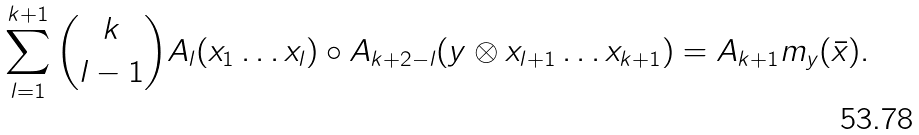Convert formula to latex. <formula><loc_0><loc_0><loc_500><loc_500>\sum _ { l = 1 } ^ { k + 1 } { k \choose l - 1 } A _ { l } ( x _ { 1 } \dots x _ { l } ) \circ A _ { k + 2 - l } ( y \otimes x _ { l + 1 } \dots x _ { k + 1 } ) = A _ { k + 1 } m _ { y } ( \bar { x } ) .</formula> 